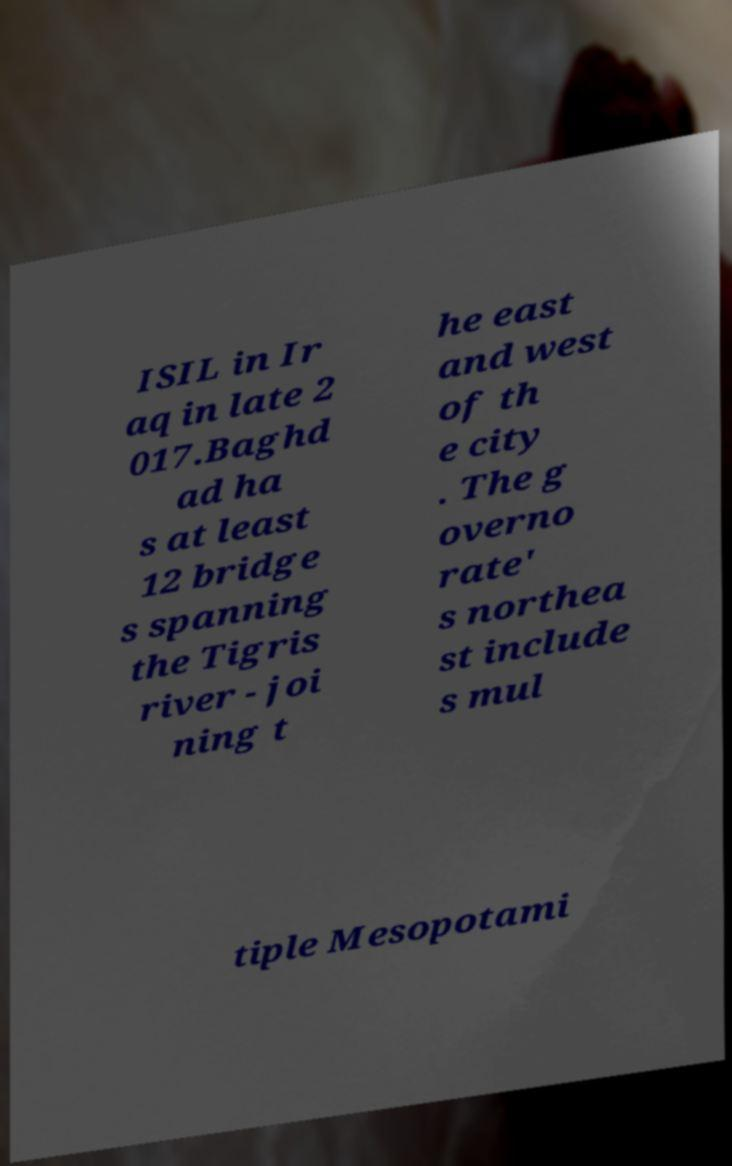Could you assist in decoding the text presented in this image and type it out clearly? ISIL in Ir aq in late 2 017.Baghd ad ha s at least 12 bridge s spanning the Tigris river - joi ning t he east and west of th e city . The g overno rate' s northea st include s mul tiple Mesopotami 